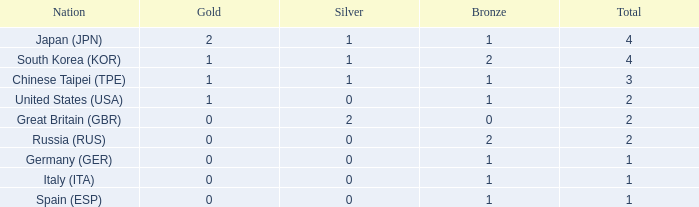What is the total medal count for a nation that has more than 1 silver medals? 2.0. 